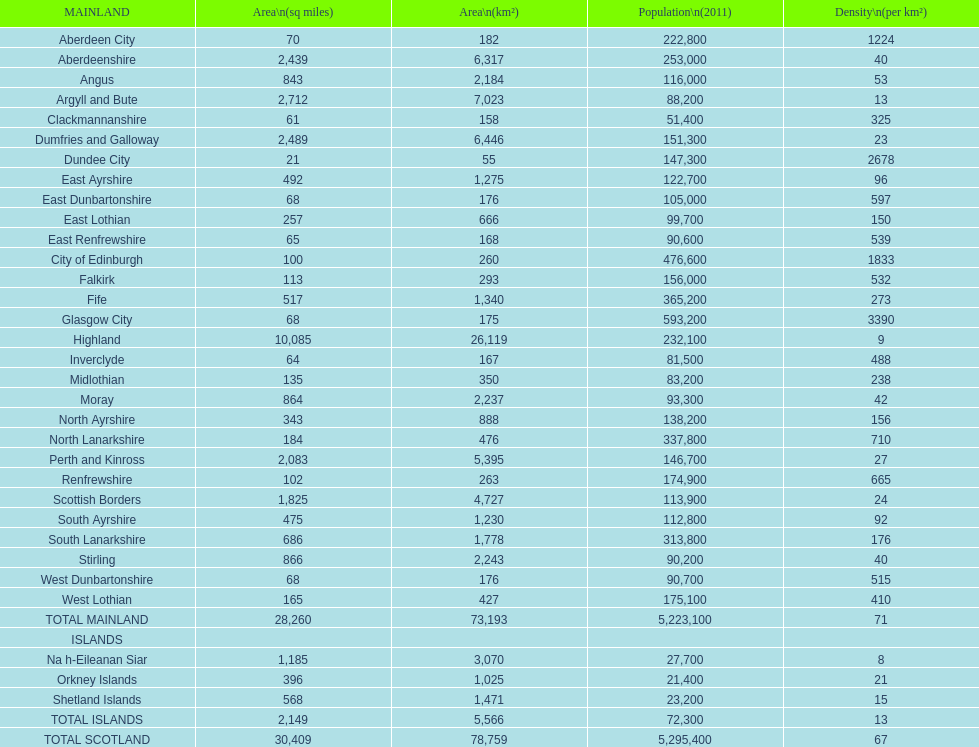If you were to arrange the locations from the smallest to largest area, which one would be first on the list? Dundee City. 